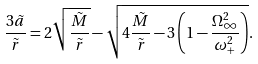<formula> <loc_0><loc_0><loc_500><loc_500>\frac { 3 \tilde { a } } { \tilde { r } } = 2 \sqrt { \frac { \tilde { M } } { \tilde { r } } } - \sqrt { 4 \frac { \tilde { M } } { \tilde { r } } - 3 \left ( 1 - \frac { \Omega _ { \infty } ^ { 2 } } { \omega _ { + } ^ { 2 } } \right ) } .</formula> 